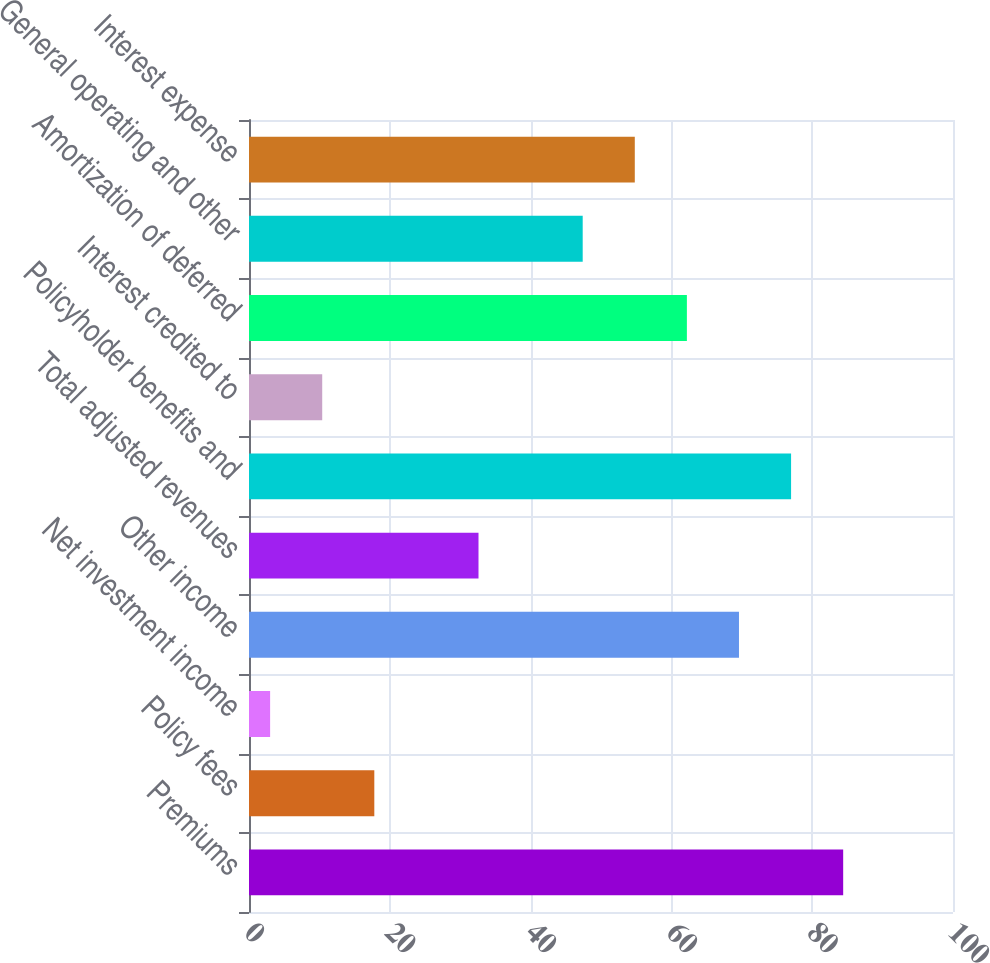Convert chart. <chart><loc_0><loc_0><loc_500><loc_500><bar_chart><fcel>Premiums<fcel>Policy fees<fcel>Net investment income<fcel>Other income<fcel>Total adjusted revenues<fcel>Policyholder benefits and<fcel>Interest credited to<fcel>Amortization of deferred<fcel>General operating and other<fcel>Interest expense<nl><fcel>84.4<fcel>17.8<fcel>3<fcel>69.6<fcel>32.6<fcel>77<fcel>10.4<fcel>62.2<fcel>47.4<fcel>54.8<nl></chart> 